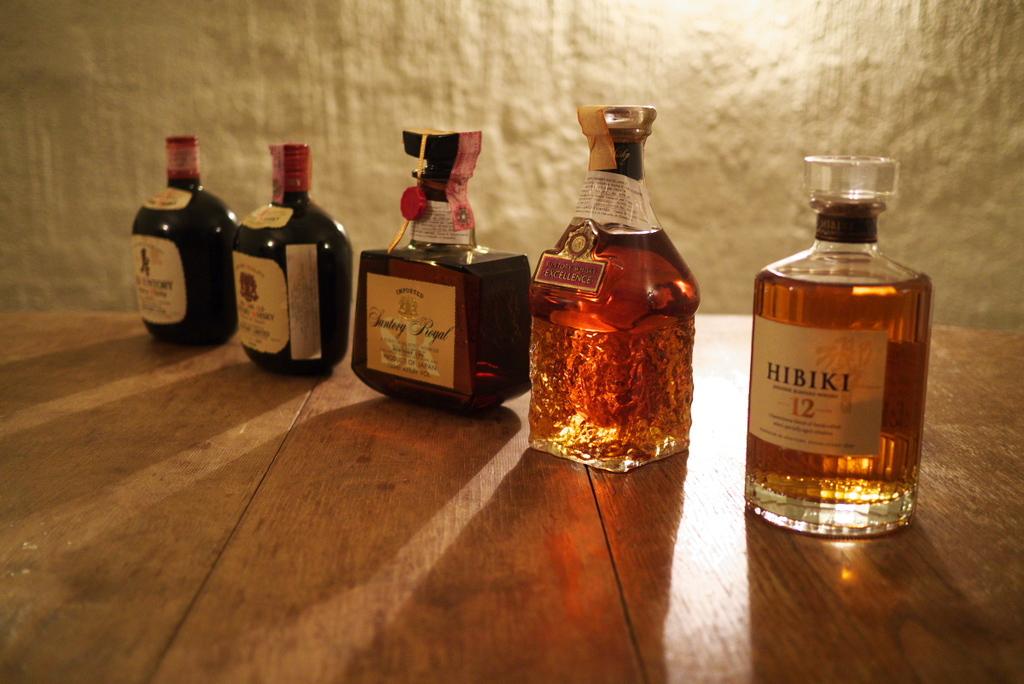Does the bottle second from the right mention excellence?
Provide a succinct answer. Yes. 